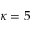<formula> <loc_0><loc_0><loc_500><loc_500>\kappa = 5</formula> 